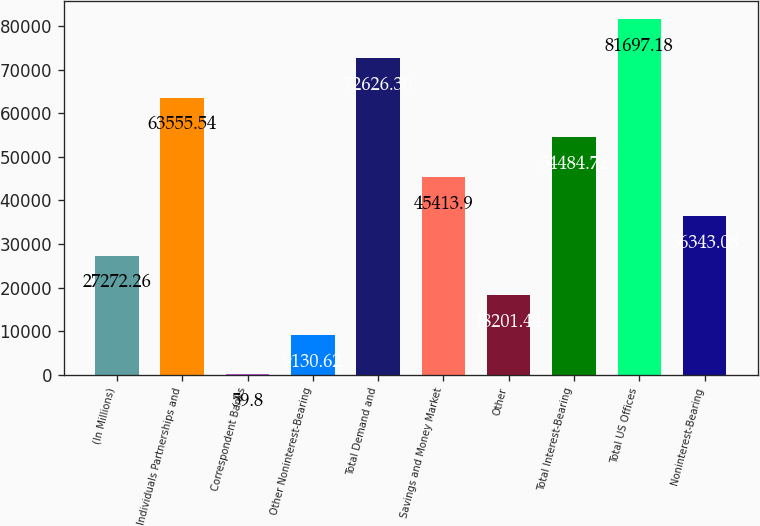Convert chart. <chart><loc_0><loc_0><loc_500><loc_500><bar_chart><fcel>(In Millions)<fcel>Individuals Partnerships and<fcel>Correspondent Banks<fcel>Other Noninterest-Bearing<fcel>Total Demand and<fcel>Savings and Money Market<fcel>Other<fcel>Total Interest-Bearing<fcel>Total US Offices<fcel>Noninterest-Bearing<nl><fcel>27272.3<fcel>63555.5<fcel>59.8<fcel>9130.62<fcel>72626.4<fcel>45413.9<fcel>18201.4<fcel>54484.7<fcel>81697.2<fcel>36343.1<nl></chart> 